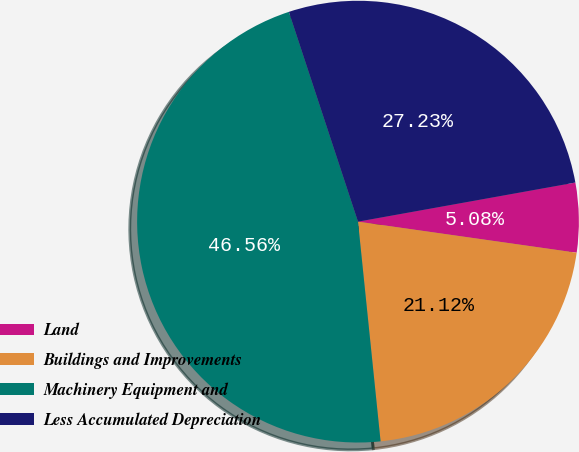Convert chart to OTSL. <chart><loc_0><loc_0><loc_500><loc_500><pie_chart><fcel>Land<fcel>Buildings and Improvements<fcel>Machinery Equipment and<fcel>Less Accumulated Depreciation<nl><fcel>5.08%<fcel>21.12%<fcel>46.56%<fcel>27.23%<nl></chart> 